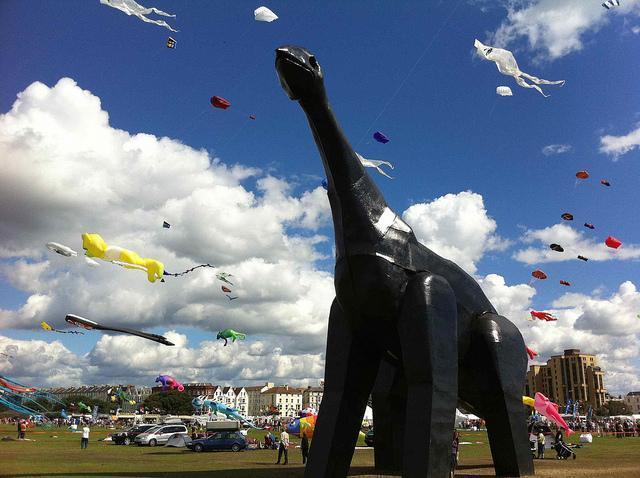What type of dinosaur does this represent?
Indicate the correct response and explain using: 'Answer: answer
Rationale: rationale.'
Options: Triceratops, t-rex, brontosaur, paradactyl. Answer: brontosaur.
Rationale: The dinosaur is a brontosaur. 